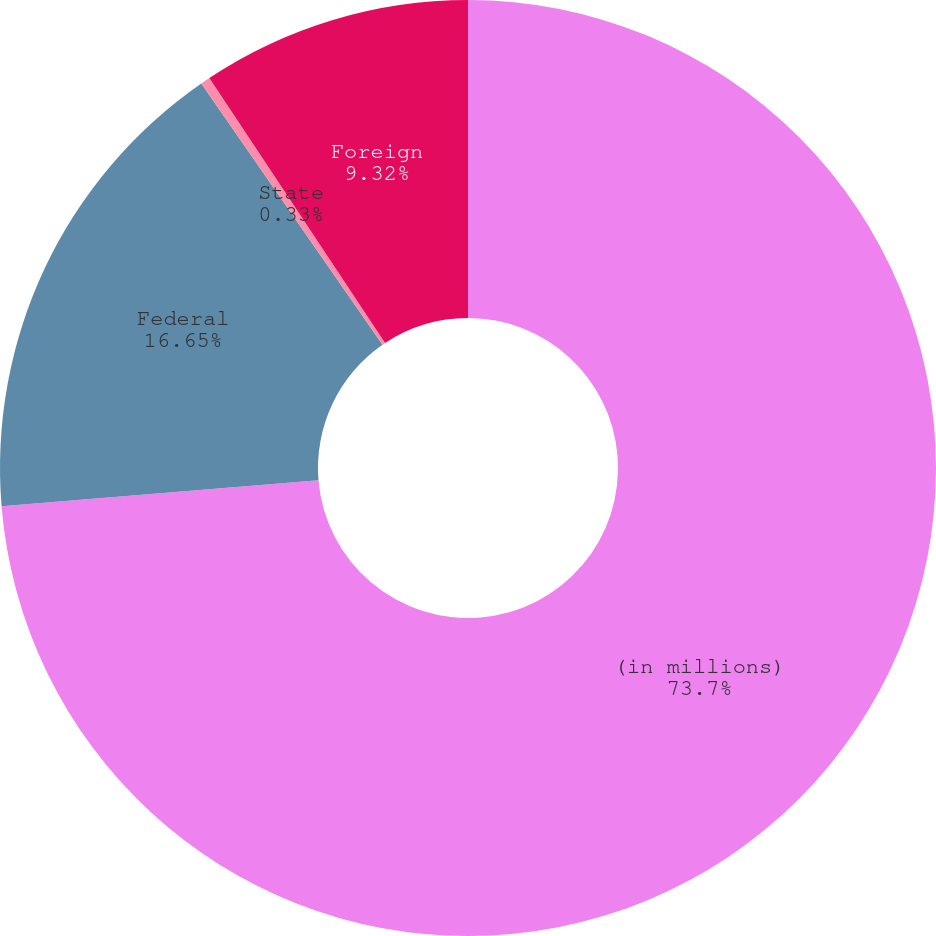<chart> <loc_0><loc_0><loc_500><loc_500><pie_chart><fcel>(in millions)<fcel>Federal<fcel>State<fcel>Foreign<nl><fcel>73.7%<fcel>16.65%<fcel>0.33%<fcel>9.32%<nl></chart> 